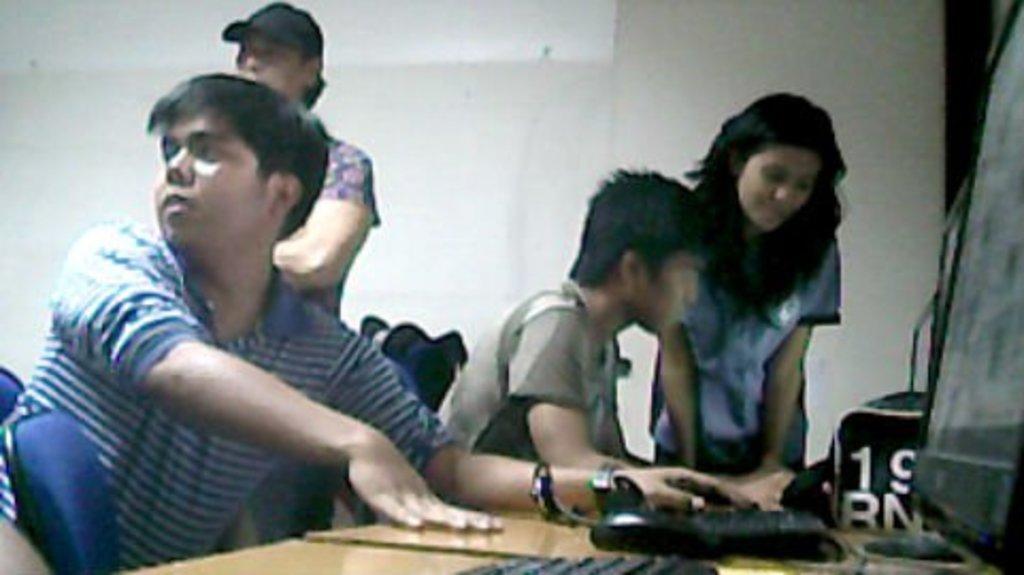Can you describe this image briefly? In this image there are persons sitting and standing. In the front there is a table and on the table there are keyboards, there is a mouse and there are monitors and there is a bag with some text and numbers written on it. In the background there is a wall which is white in colour. 